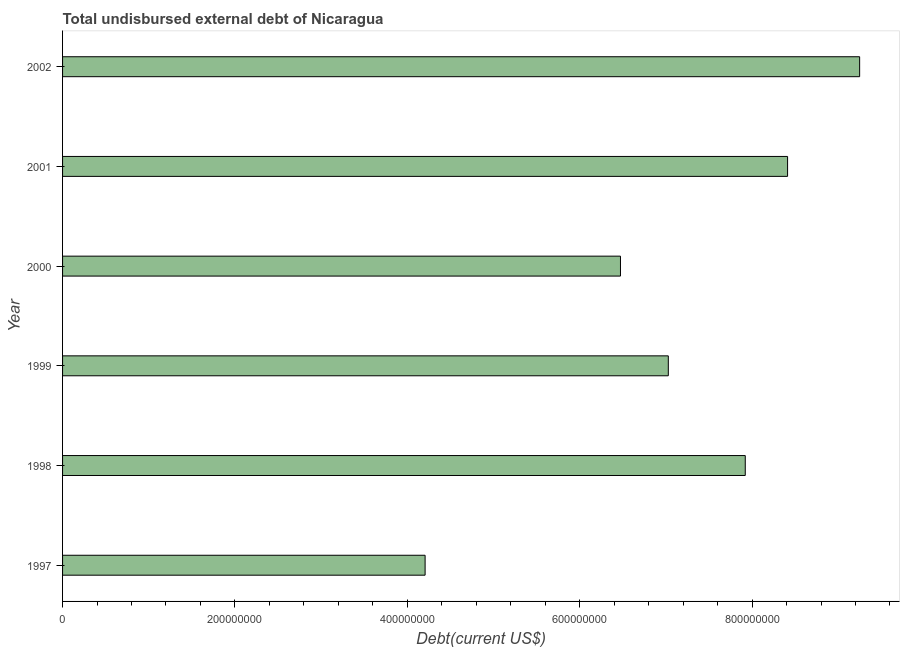Does the graph contain any zero values?
Ensure brevity in your answer.  No. Does the graph contain grids?
Keep it short and to the point. No. What is the title of the graph?
Ensure brevity in your answer.  Total undisbursed external debt of Nicaragua. What is the label or title of the X-axis?
Keep it short and to the point. Debt(current US$). What is the total debt in 1997?
Your answer should be very brief. 4.21e+08. Across all years, what is the maximum total debt?
Provide a short and direct response. 9.25e+08. Across all years, what is the minimum total debt?
Your answer should be compact. 4.21e+08. In which year was the total debt maximum?
Offer a terse response. 2002. What is the sum of the total debt?
Make the answer very short. 4.33e+09. What is the difference between the total debt in 1998 and 2002?
Give a very brief answer. -1.33e+08. What is the average total debt per year?
Your response must be concise. 7.21e+08. What is the median total debt?
Provide a short and direct response. 7.47e+08. In how many years, is the total debt greater than 880000000 US$?
Your answer should be very brief. 1. Do a majority of the years between 2001 and 1997 (inclusive) have total debt greater than 440000000 US$?
Offer a very short reply. Yes. What is the ratio of the total debt in 1999 to that in 2000?
Provide a short and direct response. 1.09. Is the total debt in 1999 less than that in 2002?
Your answer should be compact. Yes. What is the difference between the highest and the second highest total debt?
Keep it short and to the point. 8.36e+07. What is the difference between the highest and the lowest total debt?
Ensure brevity in your answer.  5.04e+08. How many bars are there?
Your response must be concise. 6. Are all the bars in the graph horizontal?
Keep it short and to the point. Yes. What is the difference between two consecutive major ticks on the X-axis?
Offer a very short reply. 2.00e+08. What is the Debt(current US$) in 1997?
Offer a very short reply. 4.21e+08. What is the Debt(current US$) of 1998?
Your answer should be compact. 7.92e+08. What is the Debt(current US$) of 1999?
Your answer should be very brief. 7.03e+08. What is the Debt(current US$) in 2000?
Provide a succinct answer. 6.47e+08. What is the Debt(current US$) in 2001?
Give a very brief answer. 8.41e+08. What is the Debt(current US$) of 2002?
Offer a very short reply. 9.25e+08. What is the difference between the Debt(current US$) in 1997 and 1998?
Provide a succinct answer. -3.71e+08. What is the difference between the Debt(current US$) in 1997 and 1999?
Your answer should be very brief. -2.82e+08. What is the difference between the Debt(current US$) in 1997 and 2000?
Keep it short and to the point. -2.27e+08. What is the difference between the Debt(current US$) in 1997 and 2001?
Your answer should be compact. -4.21e+08. What is the difference between the Debt(current US$) in 1997 and 2002?
Provide a short and direct response. -5.04e+08. What is the difference between the Debt(current US$) in 1998 and 1999?
Give a very brief answer. 8.93e+07. What is the difference between the Debt(current US$) in 1998 and 2000?
Your answer should be compact. 1.45e+08. What is the difference between the Debt(current US$) in 1998 and 2001?
Provide a short and direct response. -4.91e+07. What is the difference between the Debt(current US$) in 1998 and 2002?
Make the answer very short. -1.33e+08. What is the difference between the Debt(current US$) in 1999 and 2000?
Keep it short and to the point. 5.55e+07. What is the difference between the Debt(current US$) in 1999 and 2001?
Your answer should be compact. -1.38e+08. What is the difference between the Debt(current US$) in 1999 and 2002?
Make the answer very short. -2.22e+08. What is the difference between the Debt(current US$) in 2000 and 2001?
Keep it short and to the point. -1.94e+08. What is the difference between the Debt(current US$) in 2000 and 2002?
Give a very brief answer. -2.77e+08. What is the difference between the Debt(current US$) in 2001 and 2002?
Your response must be concise. -8.36e+07. What is the ratio of the Debt(current US$) in 1997 to that in 1998?
Offer a very short reply. 0.53. What is the ratio of the Debt(current US$) in 1997 to that in 1999?
Your answer should be very brief. 0.6. What is the ratio of the Debt(current US$) in 1997 to that in 2000?
Your answer should be compact. 0.65. What is the ratio of the Debt(current US$) in 1997 to that in 2001?
Your response must be concise. 0.5. What is the ratio of the Debt(current US$) in 1997 to that in 2002?
Provide a succinct answer. 0.46. What is the ratio of the Debt(current US$) in 1998 to that in 1999?
Make the answer very short. 1.13. What is the ratio of the Debt(current US$) in 1998 to that in 2000?
Your answer should be compact. 1.22. What is the ratio of the Debt(current US$) in 1998 to that in 2001?
Give a very brief answer. 0.94. What is the ratio of the Debt(current US$) in 1998 to that in 2002?
Your response must be concise. 0.86. What is the ratio of the Debt(current US$) in 1999 to that in 2000?
Your answer should be very brief. 1.09. What is the ratio of the Debt(current US$) in 1999 to that in 2001?
Provide a short and direct response. 0.83. What is the ratio of the Debt(current US$) in 1999 to that in 2002?
Offer a terse response. 0.76. What is the ratio of the Debt(current US$) in 2000 to that in 2001?
Offer a very short reply. 0.77. What is the ratio of the Debt(current US$) in 2000 to that in 2002?
Your answer should be compact. 0.7. What is the ratio of the Debt(current US$) in 2001 to that in 2002?
Give a very brief answer. 0.91. 